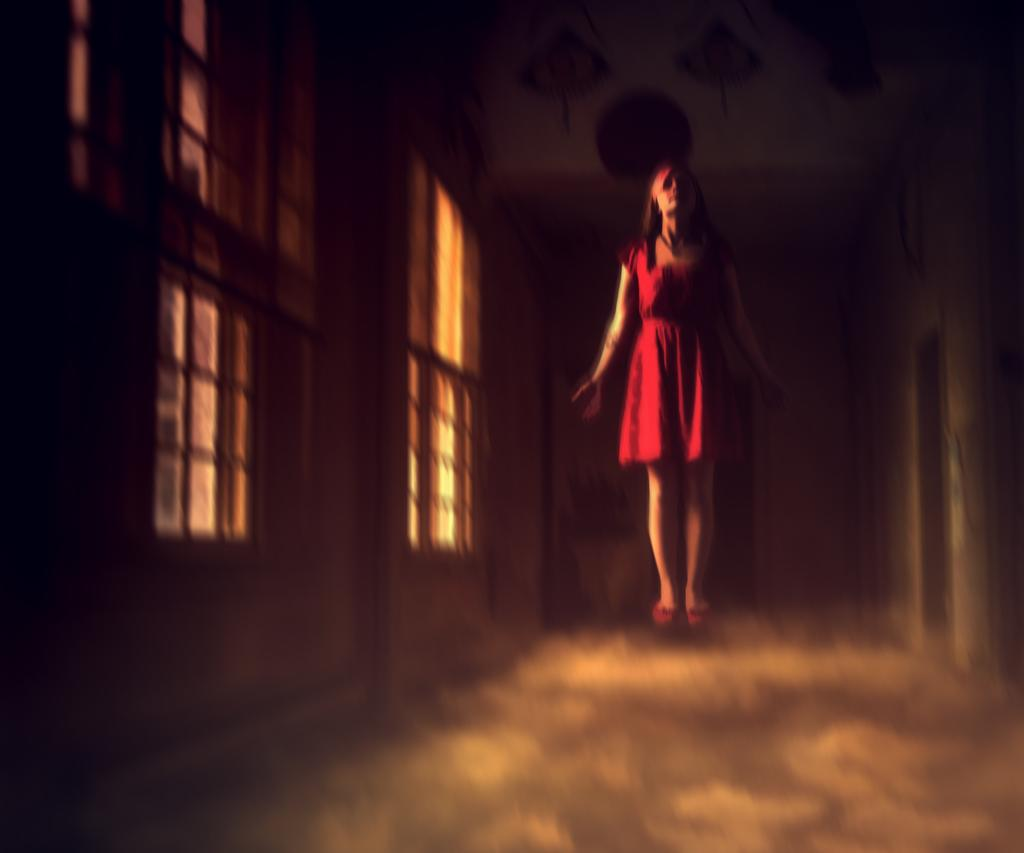Who is the main subject in the image? There is a woman in the image. What is the woman wearing? The woman is wearing a red dress. Can you describe the background of the image? The background of the image is dark. What type of underwear is the woman wearing in the image? There is no information about the woman's underwear in the image, so it cannot be determined. Can you see any fish in the image? There are no fish present in the image. 